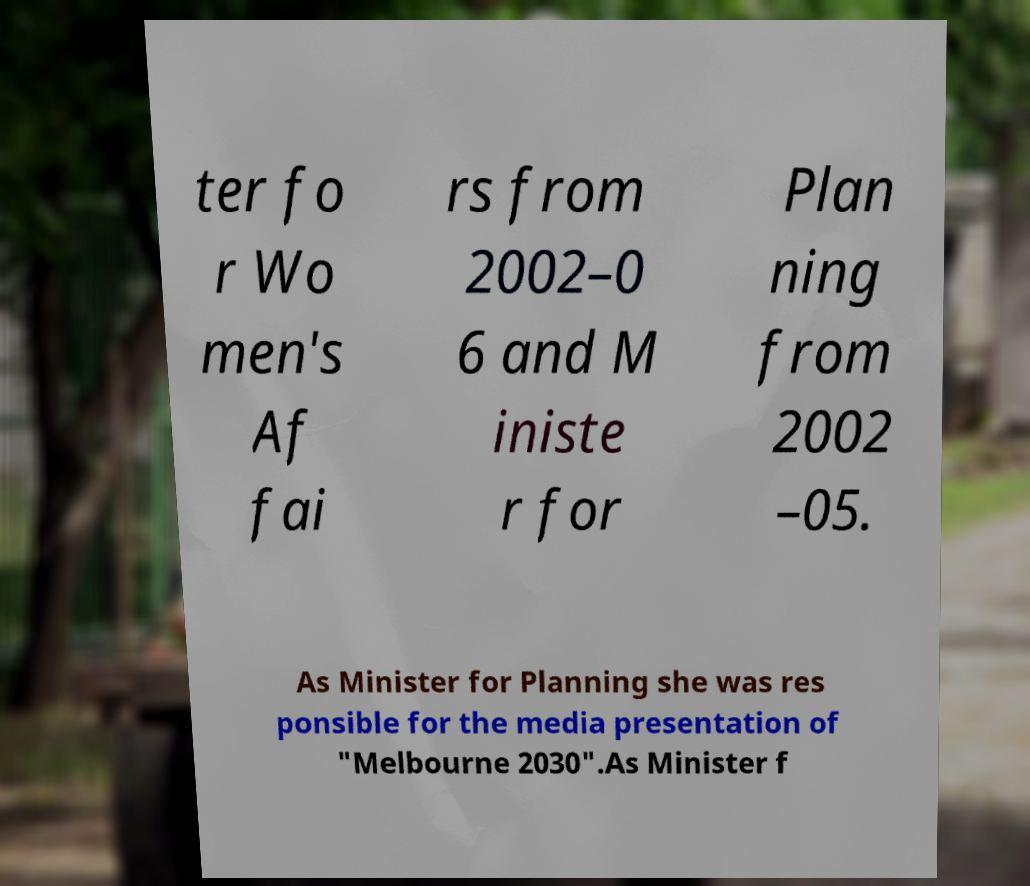I need the written content from this picture converted into text. Can you do that? ter fo r Wo men's Af fai rs from 2002–0 6 and M iniste r for Plan ning from 2002 –05. As Minister for Planning she was res ponsible for the media presentation of "Melbourne 2030".As Minister f 